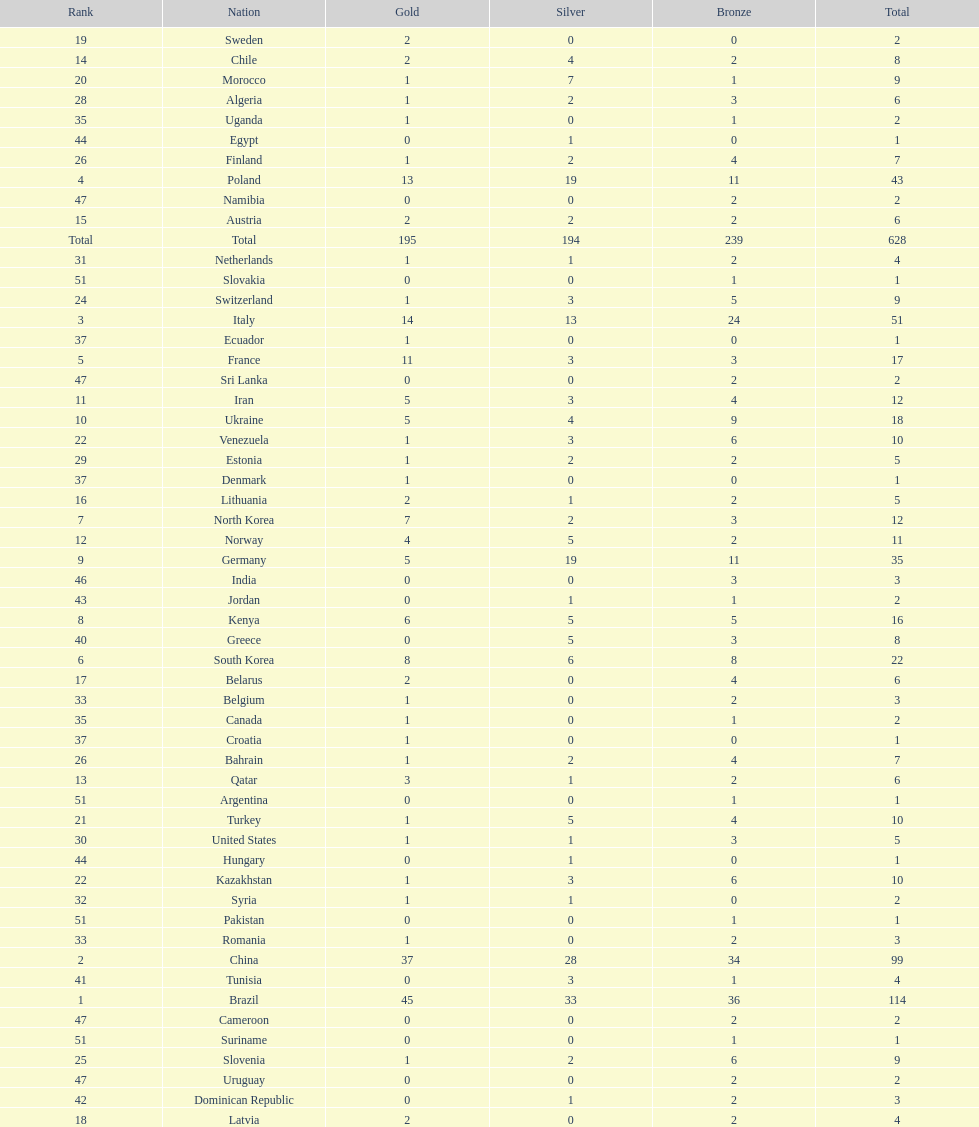How many more gold medals does china have over france? 26. 